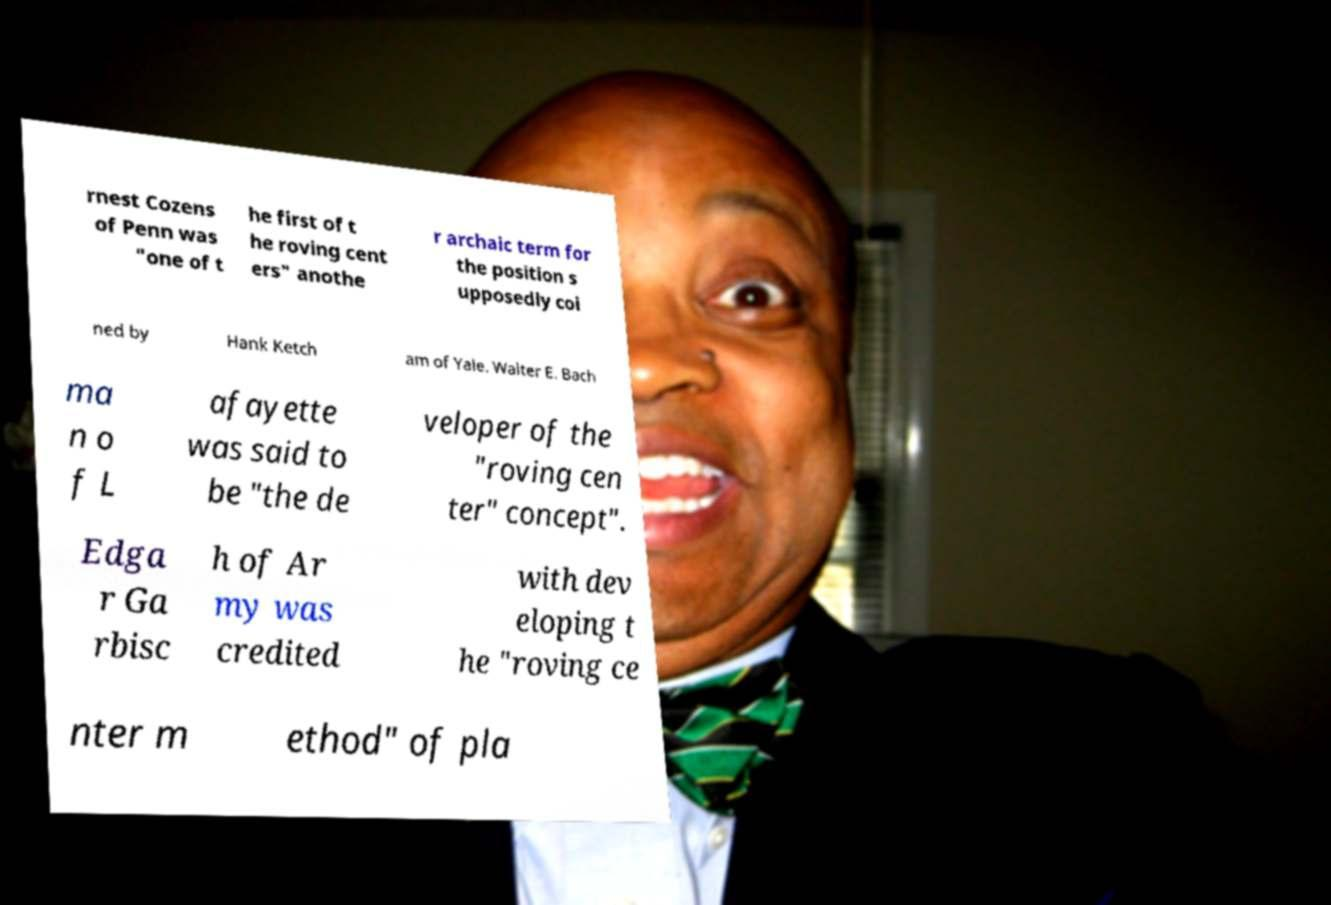I need the written content from this picture converted into text. Can you do that? rnest Cozens of Penn was "one of t he first of t he roving cent ers" anothe r archaic term for the position s upposedly coi ned by Hank Ketch am of Yale. Walter E. Bach ma n o f L afayette was said to be "the de veloper of the "roving cen ter" concept". Edga r Ga rbisc h of Ar my was credited with dev eloping t he "roving ce nter m ethod" of pla 